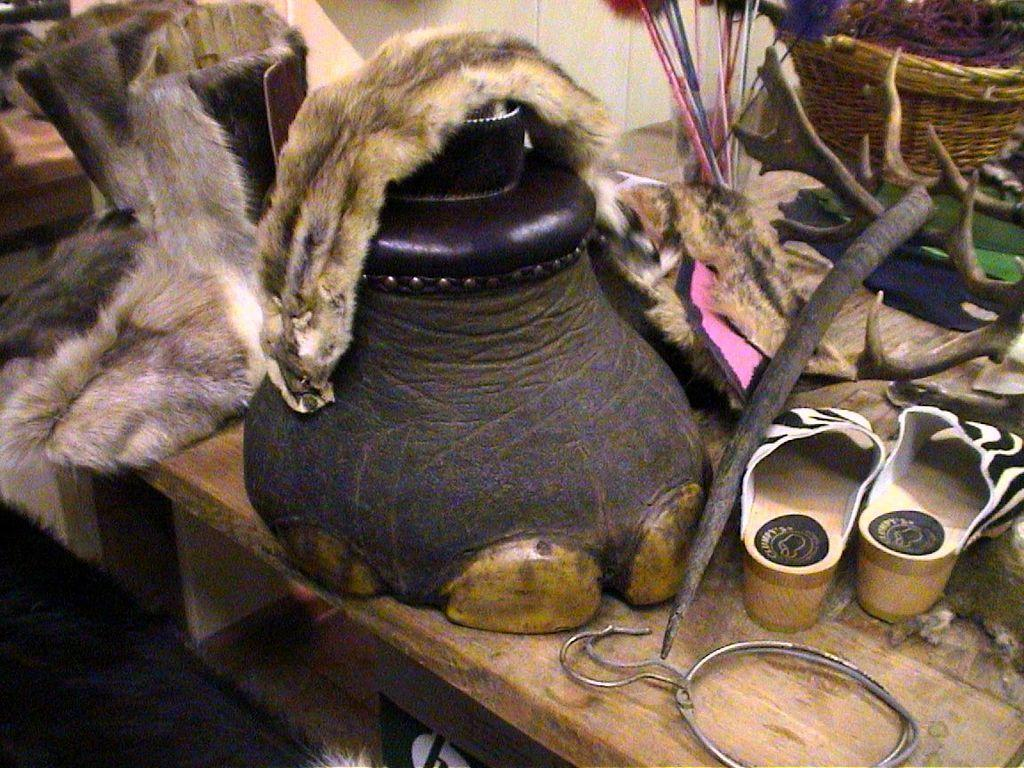What type of table is in the image? There is a wooden table in the image. What footwear can be seen on the table? There are sandals and boots on the table. What other items are on the table? There is a basket, sticks, hooks, and fur on the table. What is visible at the top of the image? There is a wall visible at the top of the image. What type of writing can be seen on the table? There is no writing visible on the table in the image. How many horses are present in the image? There are no horses present in the image. 